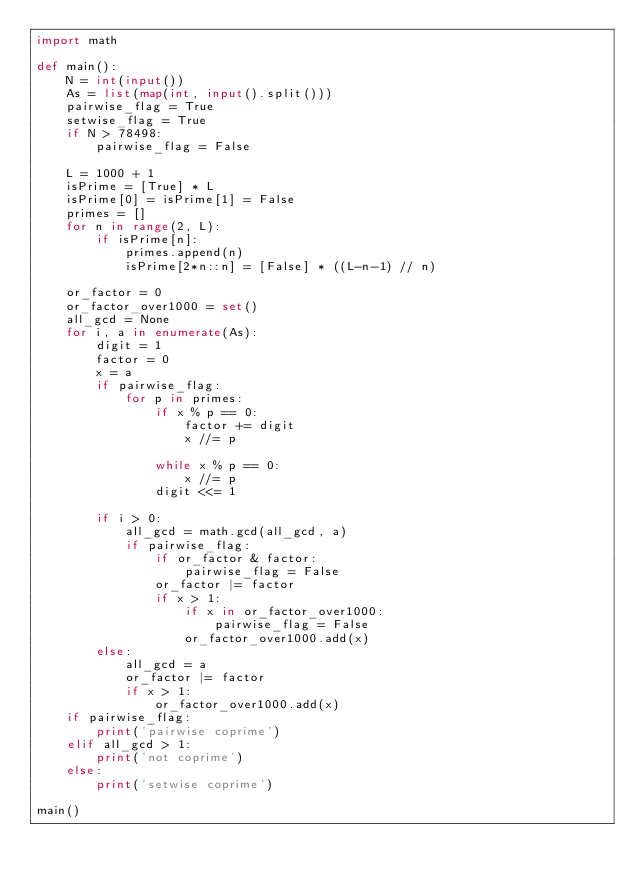Convert code to text. <code><loc_0><loc_0><loc_500><loc_500><_Python_>import math

def main():
    N = int(input())
    As = list(map(int, input().split()))
    pairwise_flag = True
    setwise_flag = True
    if N > 78498:
        pairwise_flag = False
    
    L = 1000 + 1
    isPrime = [True] * L
    isPrime[0] = isPrime[1] = False
    primes = []
    for n in range(2, L):
        if isPrime[n]:
            primes.append(n)
            isPrime[2*n::n] = [False] * ((L-n-1) // n)

    or_factor = 0
    or_factor_over1000 = set()
    all_gcd = None
    for i, a in enumerate(As):
        digit = 1
        factor = 0
        x = a
        if pairwise_flag:
            for p in primes:
                if x % p == 0:
                    factor += digit
                    x //= p

                while x % p == 0:
                    x //= p
                digit <<= 1

        if i > 0:
            all_gcd = math.gcd(all_gcd, a)
            if pairwise_flag:
                if or_factor & factor:
                    pairwise_flag = False
                or_factor |= factor
                if x > 1:
                    if x in or_factor_over1000:
                        pairwise_flag = False
                    or_factor_over1000.add(x)
        else:
            all_gcd = a
            or_factor |= factor
            if x > 1:
                or_factor_over1000.add(x)
    if pairwise_flag:
        print('pairwise coprime')
    elif all_gcd > 1:
        print('not coprime')
    else:
        print('setwise coprime')

main()
</code> 